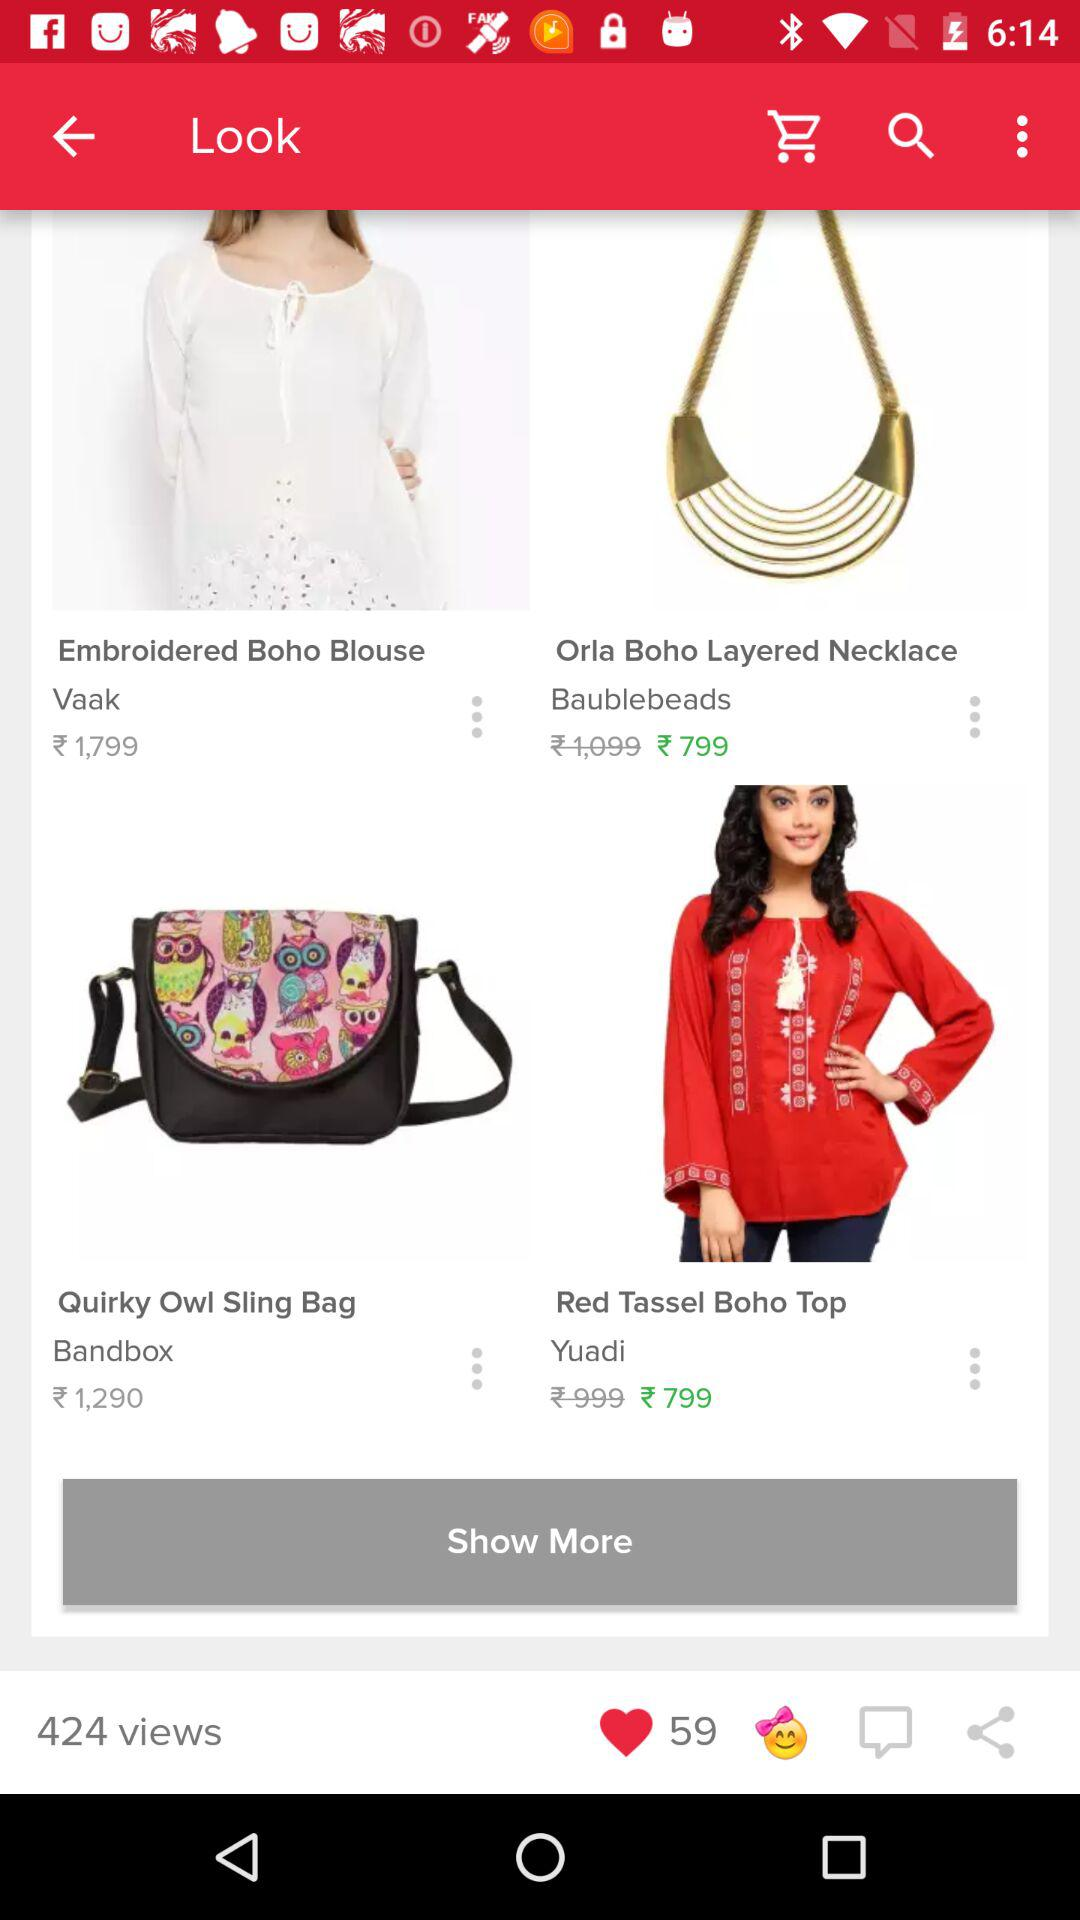How many views are there? There are 424 views. 